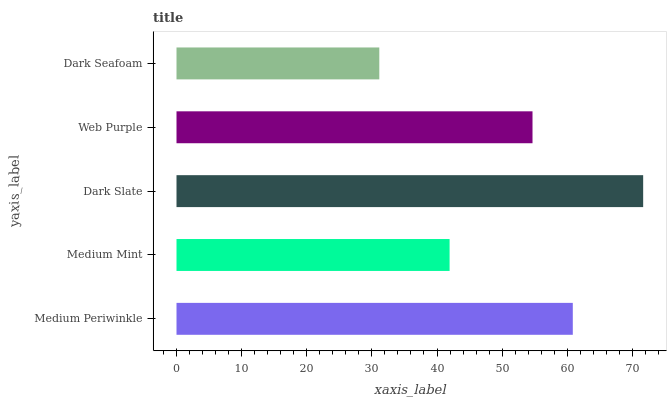Is Dark Seafoam the minimum?
Answer yes or no. Yes. Is Dark Slate the maximum?
Answer yes or no. Yes. Is Medium Mint the minimum?
Answer yes or no. No. Is Medium Mint the maximum?
Answer yes or no. No. Is Medium Periwinkle greater than Medium Mint?
Answer yes or no. Yes. Is Medium Mint less than Medium Periwinkle?
Answer yes or no. Yes. Is Medium Mint greater than Medium Periwinkle?
Answer yes or no. No. Is Medium Periwinkle less than Medium Mint?
Answer yes or no. No. Is Web Purple the high median?
Answer yes or no. Yes. Is Web Purple the low median?
Answer yes or no. Yes. Is Medium Mint the high median?
Answer yes or no. No. Is Medium Periwinkle the low median?
Answer yes or no. No. 